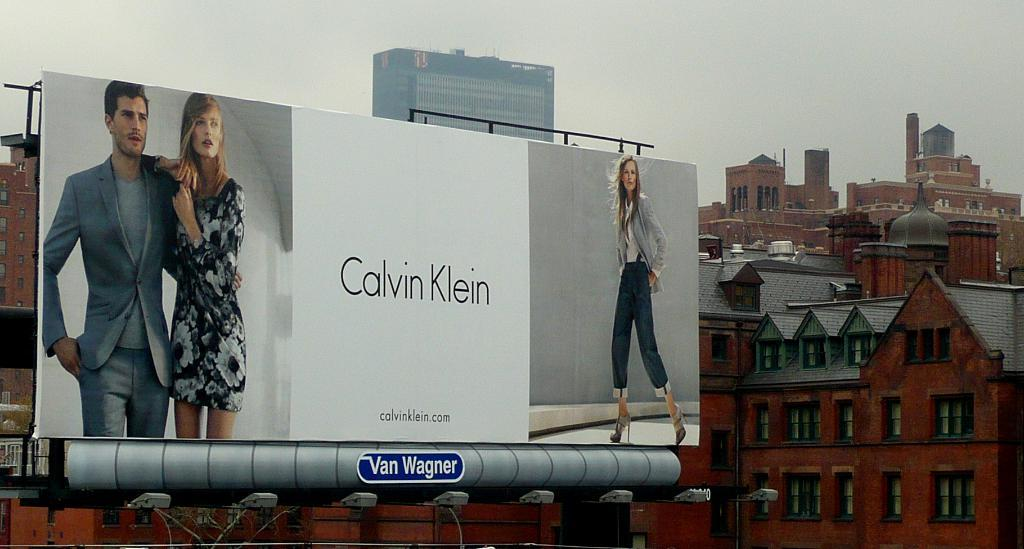Provide a one-sentence caption for the provided image. A large billboard ad for Calvin Klein in a city. 